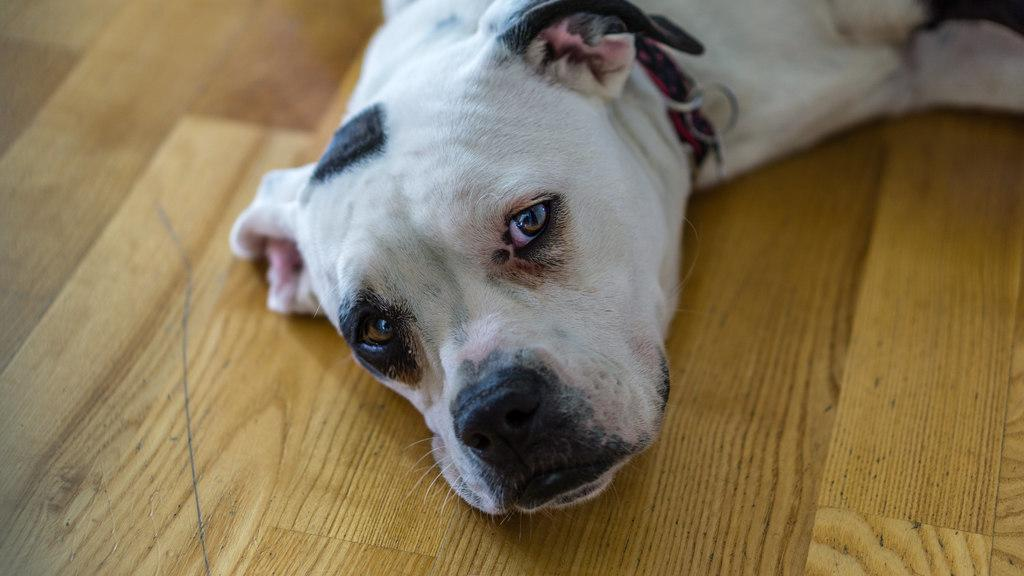What type of animal is present in the image? There is a dog in the image. What is the dog doing in the image? The dog is lying on a surface. What type of trousers is the dog wearing in the image? Dogs do not wear trousers, so this detail cannot be found in the image. 